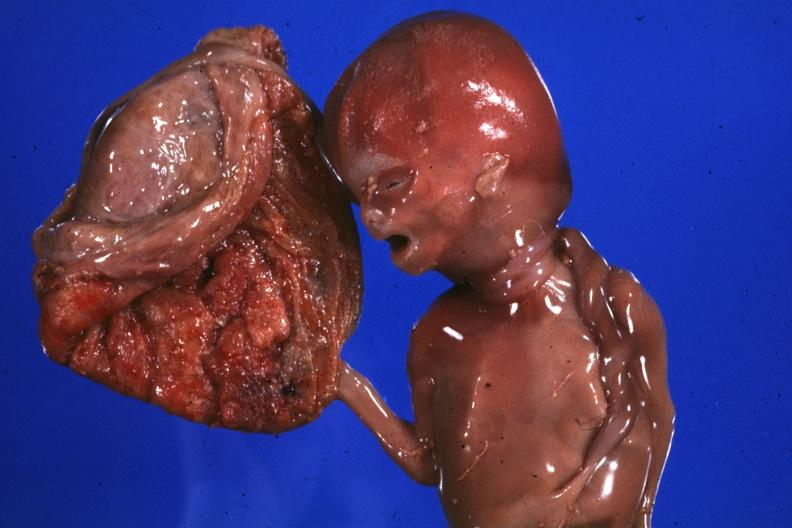does this image show macerated stillborn with two loops of cord around neck good photo?
Answer the question using a single word or phrase. Yes 